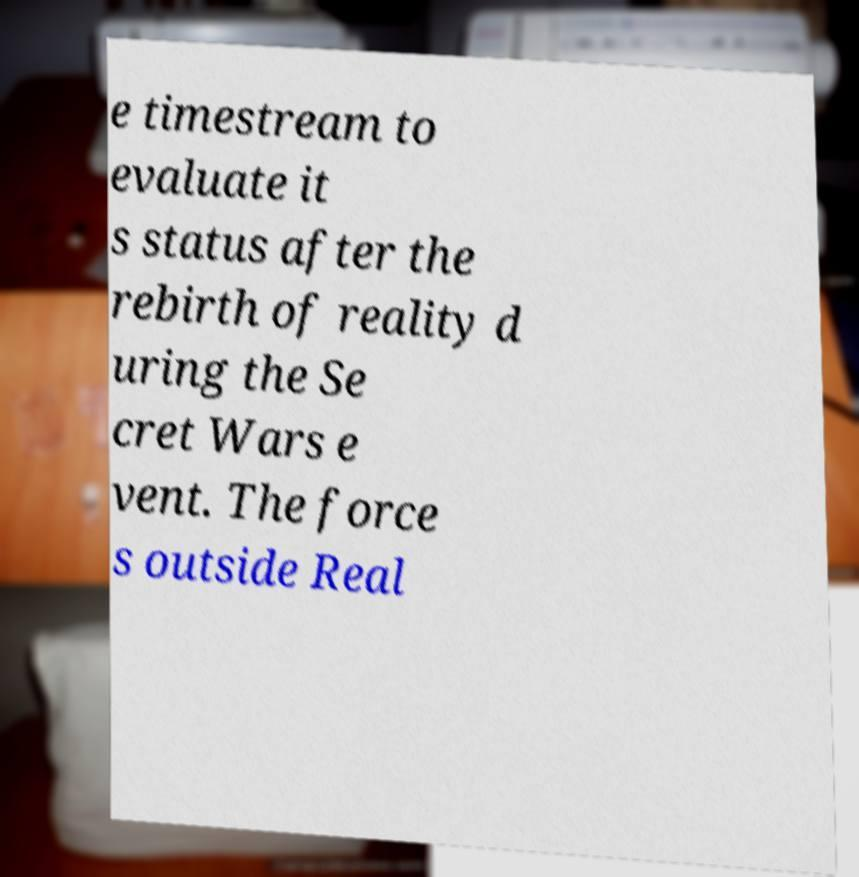What messages or text are displayed in this image? I need them in a readable, typed format. e timestream to evaluate it s status after the rebirth of reality d uring the Se cret Wars e vent. The force s outside Real 